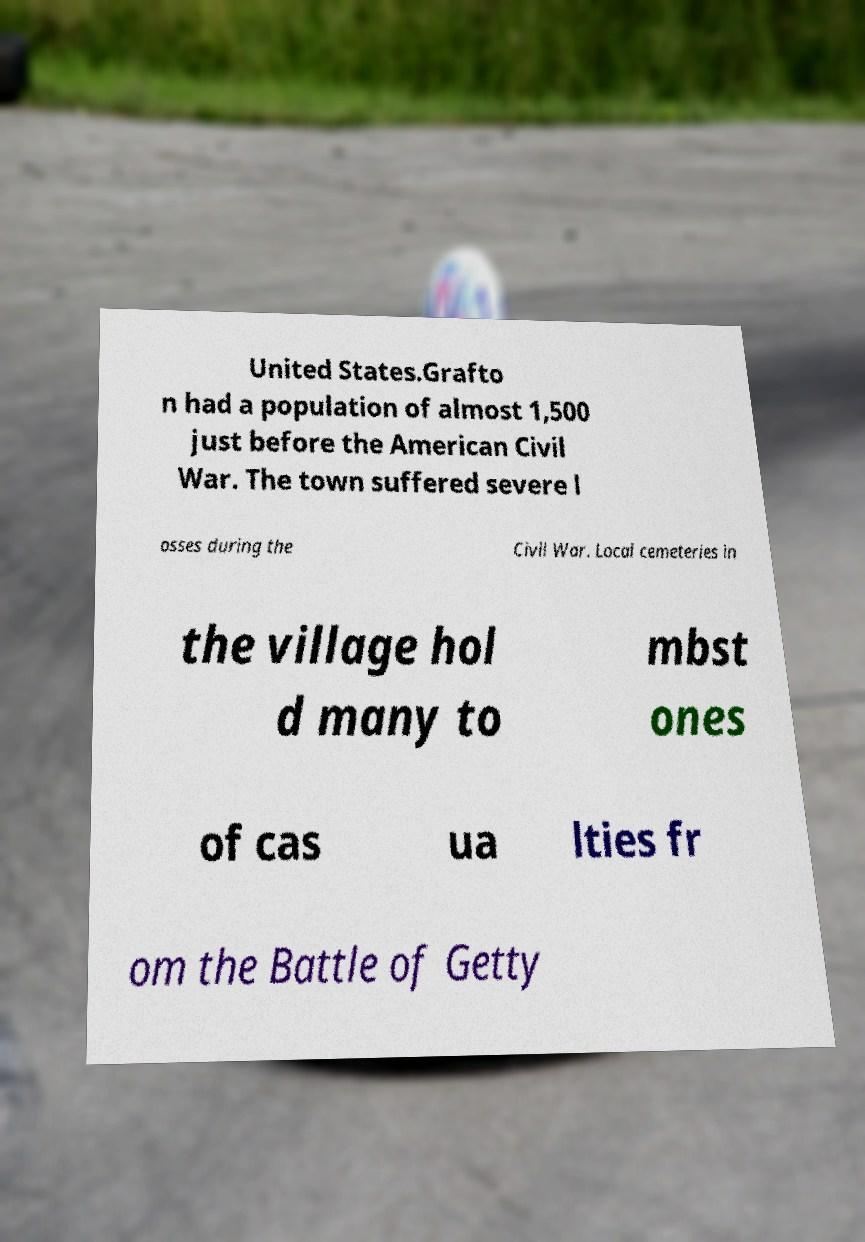There's text embedded in this image that I need extracted. Can you transcribe it verbatim? United States.Grafto n had a population of almost 1,500 just before the American Civil War. The town suffered severe l osses during the Civil War. Local cemeteries in the village hol d many to mbst ones of cas ua lties fr om the Battle of Getty 